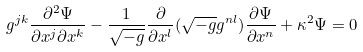<formula> <loc_0><loc_0><loc_500><loc_500>g ^ { j k } \frac { \partial ^ { 2 } \Psi } { \partial x ^ { j } \partial x ^ { k } } - \frac { 1 } { \sqrt { - g } } \frac { \partial } { \partial x ^ { l } } ( \sqrt { - g } g ^ { n l } ) \frac { \partial \Psi } { \partial x ^ { n } } + \kappa ^ { 2 } \Psi = 0</formula> 